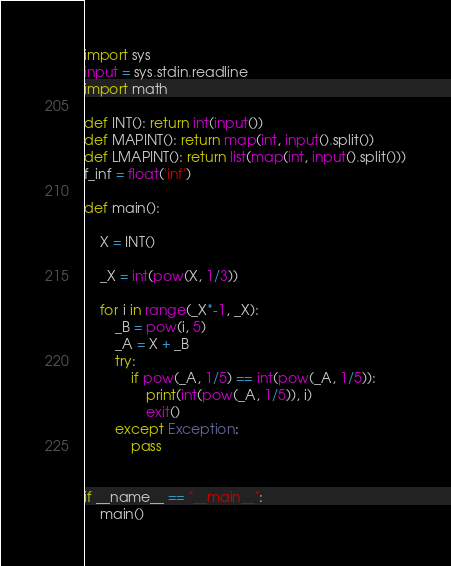Convert code to text. <code><loc_0><loc_0><loc_500><loc_500><_Cython_>import sys
input = sys.stdin.readline
import math

def INT(): return int(input())
def MAPINT(): return map(int, input().split())
def LMAPINT(): return list(map(int, input().split()))
f_inf = float('inf')

def main():

    X = INT()

    _X = int(pow(X, 1/3))

    for i in range(_X*-1, _X):
        _B = pow(i, 5)
        _A = X + _B
        try:
            if pow(_A, 1/5) == int(pow(_A, 1/5)):
                print(int(pow(_A, 1/5)), i)
                exit()
        except Exception:
            pass


if __name__ == "__main__":
    main()</code> 